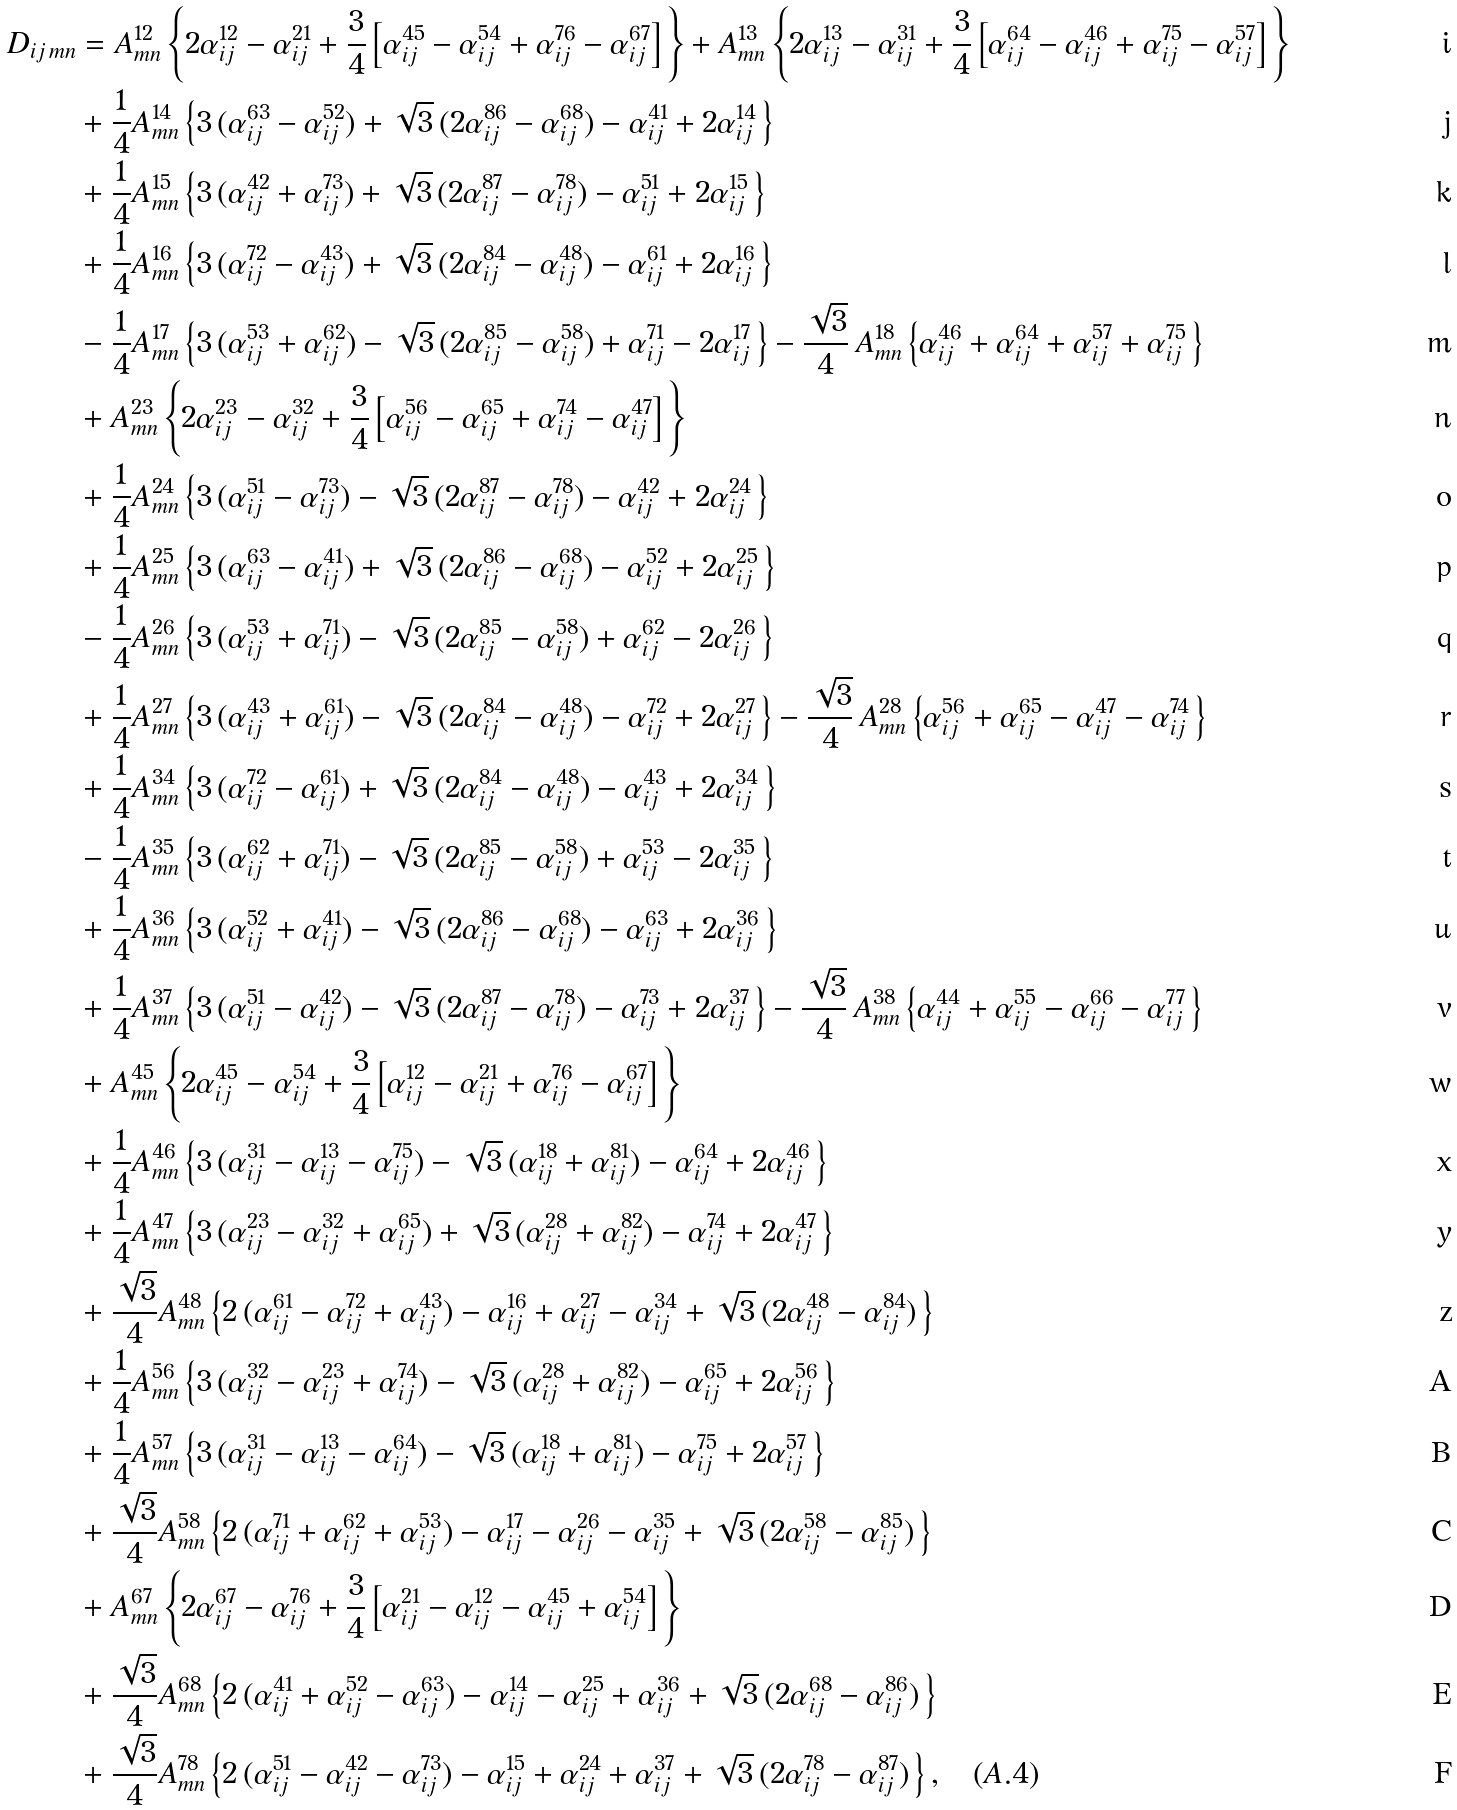Convert formula to latex. <formula><loc_0><loc_0><loc_500><loc_500>D _ { i j \, m n } & = A _ { m n } ^ { 1 2 } \left \{ 2 \alpha _ { i j } ^ { 1 2 } - \alpha _ { i j } ^ { 2 1 } + \frac { 3 } { 4 } \left [ \alpha _ { i j } ^ { 4 5 } - \alpha _ { i j } ^ { 5 4 } + \alpha _ { i j } ^ { 7 6 } - \alpha _ { i j } ^ { 6 7 } \right ] \, \right \} + A _ { m n } ^ { 1 3 } \left \{ 2 \alpha _ { i j } ^ { 1 3 } - \alpha _ { i j } ^ { 3 1 } + \frac { 3 } { 4 } \left [ \alpha _ { i j } ^ { 6 4 } - \alpha _ { i j } ^ { 4 6 } + \alpha _ { i j } ^ { 7 5 } - \alpha _ { i j } ^ { 5 7 } \right ] \, \right \} \\ & + \frac { 1 } { 4 } A _ { m n } ^ { 1 4 } \left \{ 3 \, ( \alpha _ { i j } ^ { 6 3 } - \alpha _ { i j } ^ { 5 2 } ) + \sqrt { 3 } \, ( 2 \alpha _ { i j } ^ { 8 6 } - \alpha _ { i j } ^ { 6 8 } ) - \alpha _ { i j } ^ { 4 1 } + 2 \alpha _ { i j } ^ { 1 4 } \, \right \} \\ & + \frac { 1 } { 4 } A _ { m n } ^ { 1 5 } \left \{ 3 \, ( \alpha _ { i j } ^ { 4 2 } + \alpha _ { i j } ^ { 7 3 } ) + \sqrt { 3 } \, ( 2 \alpha _ { i j } ^ { 8 7 } - \alpha _ { i j } ^ { 7 8 } ) - \alpha _ { i j } ^ { 5 1 } + 2 \alpha _ { i j } ^ { 1 5 } \, \right \} \\ & + \frac { 1 } { 4 } A _ { m n } ^ { 1 6 } \left \{ 3 \, ( \alpha _ { i j } ^ { 7 2 } - \alpha _ { i j } ^ { 4 3 } ) + \sqrt { 3 } \, ( 2 \alpha _ { i j } ^ { 8 4 } - \alpha _ { i j } ^ { 4 8 } ) - \alpha _ { i j } ^ { 6 1 } + 2 \alpha _ { i j } ^ { 1 6 } \, \right \} \\ & - \frac { 1 } { 4 } A _ { m n } ^ { 1 7 } \left \{ 3 \, ( \alpha _ { i j } ^ { 5 3 } + \alpha _ { i j } ^ { 6 2 } ) - \sqrt { 3 } \, ( 2 \alpha _ { i j } ^ { 8 5 } - \alpha _ { i j } ^ { 5 8 } ) + \alpha _ { i j } ^ { 7 1 } - 2 \alpha _ { i j } ^ { 1 7 } \, \right \} - \frac { \sqrt { 3 } } { 4 } \, A _ { m n } ^ { 1 8 } \left \{ \alpha _ { i j } ^ { 4 6 } + \alpha _ { i j } ^ { 6 4 } + \alpha _ { i j } ^ { 5 7 } + \alpha _ { i j } ^ { 7 5 } \, \right \} \\ & + A _ { m n } ^ { 2 3 } \left \{ 2 \alpha _ { i j } ^ { 2 3 } - \alpha _ { i j } ^ { 3 2 } + \frac { 3 } { 4 } \left [ \alpha _ { i j } ^ { 5 6 } - \alpha _ { i j } ^ { 6 5 } + \alpha _ { i j } ^ { 7 4 } - \alpha _ { i j } ^ { 4 7 } \right ] \, \right \} \\ & + \frac { 1 } { 4 } A _ { m n } ^ { 2 4 } \left \{ 3 \, ( \alpha _ { i j } ^ { 5 1 } - \alpha _ { i j } ^ { 7 3 } ) - \sqrt { 3 } \, ( 2 \alpha _ { i j } ^ { 8 7 } - \alpha _ { i j } ^ { 7 8 } ) - \alpha _ { i j } ^ { 4 2 } + 2 \alpha _ { i j } ^ { 2 4 } \, \right \} \\ & + \frac { 1 } { 4 } A _ { m n } ^ { 2 5 } \left \{ 3 \, ( \alpha _ { i j } ^ { 6 3 } - \alpha _ { i j } ^ { 4 1 } ) + \sqrt { 3 } \, ( 2 \alpha _ { i j } ^ { 8 6 } - \alpha _ { i j } ^ { 6 8 } ) - \alpha _ { i j } ^ { 5 2 } + 2 \alpha _ { i j } ^ { 2 5 } \, \right \} \\ & - \frac { 1 } { 4 } A _ { m n } ^ { 2 6 } \left \{ 3 \, ( \alpha _ { i j } ^ { 5 3 } + \alpha _ { i j } ^ { 7 1 } ) - \sqrt { 3 } \, ( 2 \alpha _ { i j } ^ { 8 5 } - \alpha _ { i j } ^ { 5 8 } ) + \alpha _ { i j } ^ { 6 2 } - 2 \alpha _ { i j } ^ { 2 6 } \, \right \} \\ & + \frac { 1 } { 4 } A _ { m n } ^ { 2 7 } \left \{ 3 \, ( \alpha _ { i j } ^ { 4 3 } + \alpha _ { i j } ^ { 6 1 } ) - \sqrt { 3 } \, ( 2 \alpha _ { i j } ^ { 8 4 } - \alpha _ { i j } ^ { 4 8 } ) - \alpha _ { i j } ^ { 7 2 } + 2 \alpha _ { i j } ^ { 2 7 } \, \right \} - \frac { \sqrt { 3 } } { 4 } \, A _ { m n } ^ { 2 8 } \left \{ \alpha _ { i j } ^ { 5 6 } + \alpha _ { i j } ^ { 6 5 } - \alpha _ { i j } ^ { 4 7 } - \alpha _ { i j } ^ { 7 4 } \, \right \} \\ & + \frac { 1 } { 4 } A _ { m n } ^ { 3 4 } \left \{ 3 \, ( \alpha _ { i j } ^ { 7 2 } - \alpha _ { i j } ^ { 6 1 } ) + \sqrt { 3 } \, ( 2 \alpha _ { i j } ^ { 8 4 } - \alpha _ { i j } ^ { 4 8 } ) - \alpha _ { i j } ^ { 4 3 } + 2 \alpha _ { i j } ^ { 3 4 } \, \right \} \\ & - \frac { 1 } { 4 } A _ { m n } ^ { 3 5 } \left \{ 3 \, ( \alpha _ { i j } ^ { 6 2 } + \alpha _ { i j } ^ { 7 1 } ) - \sqrt { 3 } \, ( 2 \alpha _ { i j } ^ { 8 5 } - \alpha _ { i j } ^ { 5 8 } ) + \alpha _ { i j } ^ { 5 3 } - 2 \alpha _ { i j } ^ { 3 5 } \, \right \} \\ & + \frac { 1 } { 4 } A _ { m n } ^ { 3 6 } \left \{ 3 \, ( \alpha _ { i j } ^ { 5 2 } + \alpha _ { i j } ^ { 4 1 } ) - \sqrt { 3 } \, ( 2 \alpha _ { i j } ^ { 8 6 } - \alpha _ { i j } ^ { 6 8 } ) - \alpha _ { i j } ^ { 6 3 } + 2 \alpha _ { i j } ^ { 3 6 } \, \right \} \\ & + \frac { 1 } { 4 } A _ { m n } ^ { 3 7 } \left \{ 3 \, ( \alpha _ { i j } ^ { 5 1 } - \alpha _ { i j } ^ { 4 2 } ) - \sqrt { 3 } \, ( 2 \alpha _ { i j } ^ { 8 7 } - \alpha _ { i j } ^ { 7 8 } ) - \alpha _ { i j } ^ { 7 3 } + 2 \alpha _ { i j } ^ { 3 7 } \, \right \} - \frac { \sqrt { 3 } } { 4 } \, A _ { m n } ^ { 3 8 } \left \{ \alpha _ { i j } ^ { 4 4 } + \alpha _ { i j } ^ { 5 5 } - \alpha _ { i j } ^ { 6 6 } - \alpha _ { i j } ^ { 7 7 } \, \right \} \\ & + A _ { m n } ^ { 4 5 } \left \{ 2 \alpha _ { i j } ^ { 4 5 } - \alpha _ { i j } ^ { 5 4 } + \frac { 3 } { 4 } \left [ \alpha _ { i j } ^ { 1 2 } - \alpha _ { i j } ^ { 2 1 } + \alpha _ { i j } ^ { 7 6 } - \alpha _ { i j } ^ { 6 7 } \right ] \, \right \} \\ & + \frac { 1 } { 4 } A _ { m n } ^ { 4 6 } \left \{ 3 \, ( \alpha _ { i j } ^ { 3 1 } - \alpha _ { i j } ^ { 1 3 } - \alpha _ { i j } ^ { 7 5 } ) - \sqrt { 3 } \, ( \alpha _ { i j } ^ { 1 8 } + \alpha _ { i j } ^ { 8 1 } ) - \alpha _ { i j } ^ { 6 4 } + 2 \alpha _ { i j } ^ { 4 6 } \, \right \} \\ & + \frac { 1 } { 4 } A _ { m n } ^ { 4 7 } \left \{ 3 \, ( \alpha _ { i j } ^ { 2 3 } - \alpha _ { i j } ^ { 3 2 } + \alpha _ { i j } ^ { 6 5 } ) + \sqrt { 3 } \, ( \alpha _ { i j } ^ { 2 8 } + \alpha _ { i j } ^ { 8 2 } ) - \alpha _ { i j } ^ { 7 4 } + 2 \alpha _ { i j } ^ { 4 7 } \, \right \} \\ & + \frac { \sqrt { 3 } } 4 A _ { m n } ^ { 4 8 } \left \{ 2 \, ( \alpha _ { i j } ^ { 6 1 } - \alpha _ { i j } ^ { 7 2 } + \alpha _ { i j } ^ { 4 3 } ) - \alpha _ { i j } ^ { 1 6 } + \alpha _ { i j } ^ { 2 7 } - \alpha _ { i j } ^ { 3 4 } + \sqrt { 3 } \, ( 2 \alpha _ { i j } ^ { 4 8 } - \alpha _ { i j } ^ { 8 4 } ) \, \right \} \\ & + \frac { 1 } { 4 } A _ { m n } ^ { 5 6 } \left \{ 3 \, ( \alpha _ { i j } ^ { 3 2 } - \alpha _ { i j } ^ { 2 3 } + \alpha _ { i j } ^ { 7 4 } ) - \sqrt { 3 } \, ( \alpha _ { i j } ^ { 2 8 } + \alpha _ { i j } ^ { 8 2 } ) - \alpha _ { i j } ^ { 6 5 } + 2 \alpha _ { i j } ^ { 5 6 } \, \right \} \\ & + \frac { 1 } { 4 } A _ { m n } ^ { 5 7 } \left \{ 3 \, ( \alpha _ { i j } ^ { 3 1 } - \alpha _ { i j } ^ { 1 3 } - \alpha _ { i j } ^ { 6 4 } ) - \sqrt { 3 } \, ( \alpha _ { i j } ^ { 1 8 } + \alpha _ { i j } ^ { 8 1 } ) - \alpha _ { i j } ^ { 7 5 } + 2 \alpha _ { i j } ^ { 5 7 } \, \right \} \\ & + \frac { \sqrt { 3 } } 4 A _ { m n } ^ { 5 8 } \left \{ 2 \, ( \alpha _ { i j } ^ { 7 1 } + \alpha _ { i j } ^ { 6 2 } + \alpha _ { i j } ^ { 5 3 } ) - \alpha _ { i j } ^ { 1 7 } - \alpha _ { i j } ^ { 2 6 } - \alpha _ { i j } ^ { 3 5 } + \sqrt { 3 } \, ( 2 \alpha _ { i j } ^ { 5 8 } - \alpha _ { i j } ^ { 8 5 } ) \, \right \} \\ & + A _ { m n } ^ { 6 7 } \left \{ 2 \alpha _ { i j } ^ { 6 7 } - \alpha _ { i j } ^ { 7 6 } + \frac { 3 } { 4 } \left [ \alpha _ { i j } ^ { 2 1 } - \alpha _ { i j } ^ { 1 2 } - \alpha _ { i j } ^ { 4 5 } + \alpha _ { i j } ^ { 5 4 } \right ] \, \right \} \\ & + \frac { \sqrt { 3 } } 4 A _ { m n } ^ { 6 8 } \left \{ 2 \, ( \alpha _ { i j } ^ { 4 1 } + \alpha _ { i j } ^ { 5 2 } - \alpha _ { i j } ^ { 6 3 } ) - \alpha _ { i j } ^ { 1 4 } - \alpha _ { i j } ^ { 2 5 } + \alpha _ { i j } ^ { 3 6 } + \sqrt { 3 } \, ( 2 \alpha _ { i j } ^ { 6 8 } - \alpha _ { i j } ^ { 8 6 } ) \, \right \} \\ & + \frac { \sqrt { 3 } } 4 A _ { m n } ^ { 7 8 } \left \{ 2 \, ( \alpha _ { i j } ^ { 5 1 } - \alpha _ { i j } ^ { 4 2 } - \alpha _ { i j } ^ { 7 3 } ) - \alpha _ { i j } ^ { 1 5 } + \alpha _ { i j } ^ { 2 4 } + \alpha _ { i j } ^ { 3 7 } + \sqrt { 3 } \, ( 2 \alpha _ { i j } ^ { 7 8 } - \alpha _ { i j } ^ { 8 7 } ) \, \right \} , \quad ( A . 4 )</formula> 